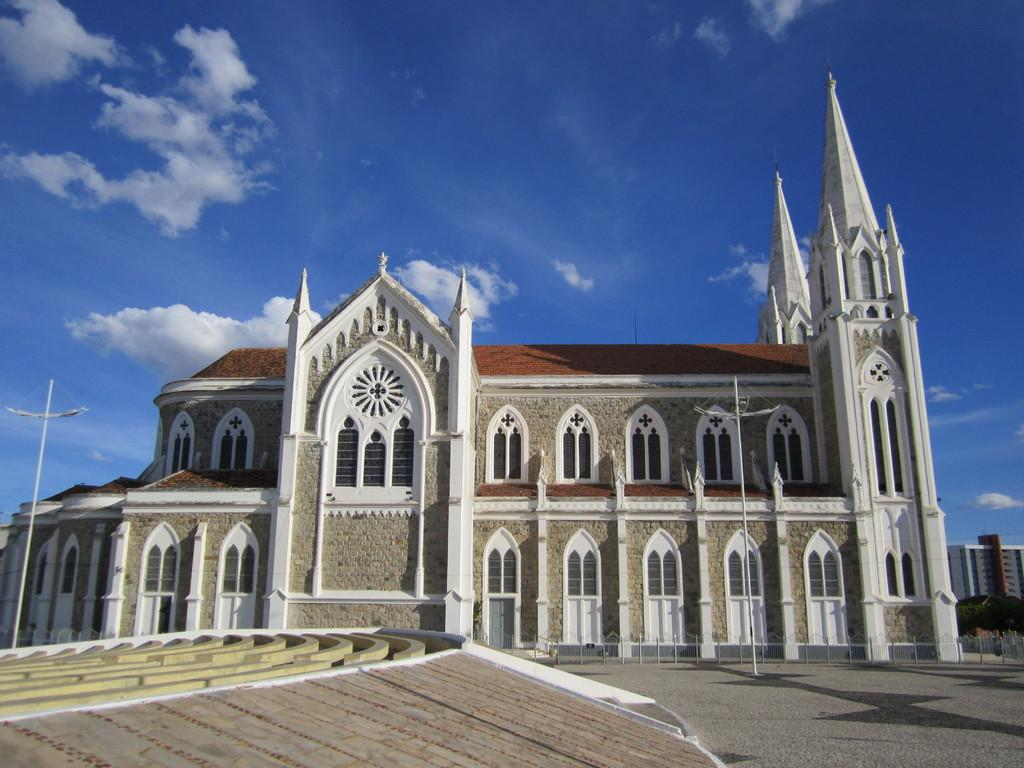What type of building is in the image? There is a church building in the image. Are there any other structures or objects near the church building? Yes, there are two lamp posts in front of the church building. Who is the manager of the chess game taking place inside the church building? There is no chess game or manager mentioned in the image; it only features a church building and two lamp posts. 